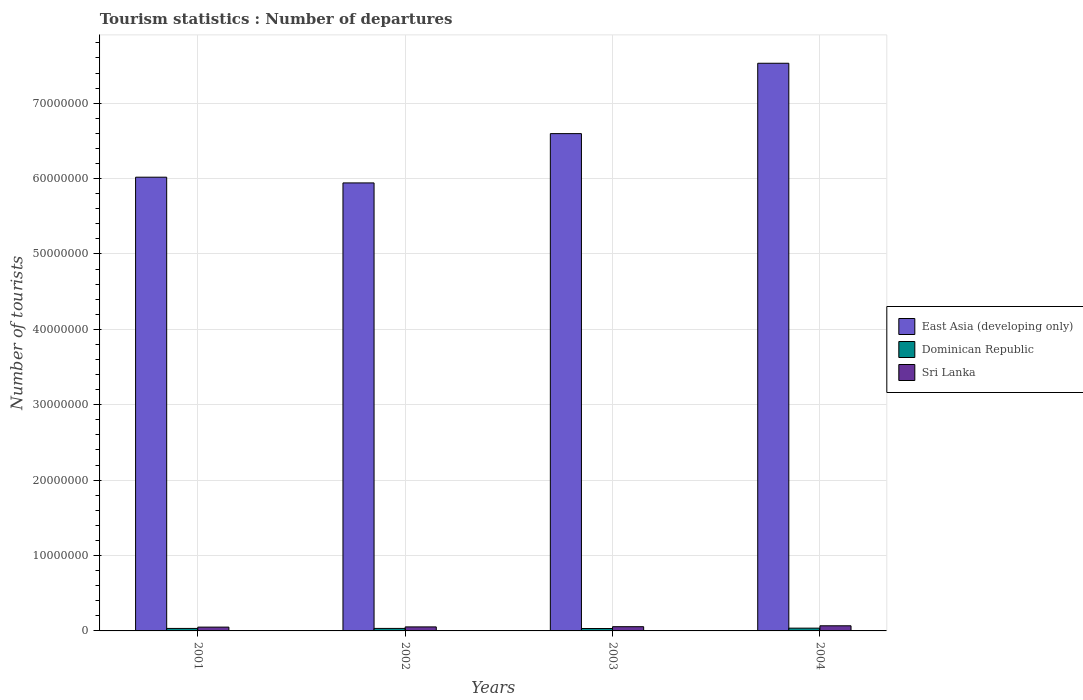How many groups of bars are there?
Your answer should be very brief. 4. Are the number of bars on each tick of the X-axis equal?
Keep it short and to the point. Yes. How many bars are there on the 2nd tick from the left?
Ensure brevity in your answer.  3. What is the number of tourist departures in East Asia (developing only) in 2004?
Provide a succinct answer. 7.53e+07. Across all years, what is the maximum number of tourist departures in East Asia (developing only)?
Make the answer very short. 7.53e+07. Across all years, what is the minimum number of tourist departures in Sri Lanka?
Make the answer very short. 5.05e+05. In which year was the number of tourist departures in Sri Lanka maximum?
Provide a succinct answer. 2004. In which year was the number of tourist departures in Dominican Republic minimum?
Make the answer very short. 2003. What is the total number of tourist departures in Sri Lanka in the graph?
Your response must be concise. 2.28e+06. What is the difference between the number of tourist departures in Dominican Republic in 2002 and that in 2003?
Your answer should be compact. 1.10e+04. What is the difference between the number of tourist departures in Sri Lanka in 2001 and the number of tourist departures in Dominican Republic in 2004?
Make the answer very short. 1.37e+05. What is the average number of tourist departures in East Asia (developing only) per year?
Ensure brevity in your answer.  6.52e+07. In the year 2001, what is the difference between the number of tourist departures in Sri Lanka and number of tourist departures in East Asia (developing only)?
Ensure brevity in your answer.  -5.97e+07. In how many years, is the number of tourist departures in Sri Lanka greater than 28000000?
Make the answer very short. 0. What is the ratio of the number of tourist departures in Dominican Republic in 2002 to that in 2004?
Provide a short and direct response. 0.9. Is the number of tourist departures in Dominican Republic in 2001 less than that in 2004?
Offer a very short reply. Yes. Is the difference between the number of tourist departures in Sri Lanka in 2002 and 2003 greater than the difference between the number of tourist departures in East Asia (developing only) in 2002 and 2003?
Keep it short and to the point. Yes. What is the difference between the highest and the second highest number of tourist departures in East Asia (developing only)?
Your answer should be very brief. 9.33e+06. What is the difference between the highest and the lowest number of tourist departures in Sri Lanka?
Give a very brief answer. 1.75e+05. In how many years, is the number of tourist departures in Dominican Republic greater than the average number of tourist departures in Dominican Republic taken over all years?
Provide a short and direct response. 1. Is the sum of the number of tourist departures in Sri Lanka in 2001 and 2004 greater than the maximum number of tourist departures in East Asia (developing only) across all years?
Provide a short and direct response. No. What does the 3rd bar from the left in 2003 represents?
Make the answer very short. Sri Lanka. What does the 2nd bar from the right in 2001 represents?
Ensure brevity in your answer.  Dominican Republic. How many years are there in the graph?
Offer a very short reply. 4. Are the values on the major ticks of Y-axis written in scientific E-notation?
Offer a very short reply. No. Does the graph contain any zero values?
Your answer should be compact. No. Where does the legend appear in the graph?
Make the answer very short. Center right. How many legend labels are there?
Your response must be concise. 3. What is the title of the graph?
Ensure brevity in your answer.  Tourism statistics : Number of departures. Does "Romania" appear as one of the legend labels in the graph?
Offer a very short reply. No. What is the label or title of the Y-axis?
Your response must be concise. Number of tourists. What is the Number of tourists in East Asia (developing only) in 2001?
Provide a short and direct response. 6.02e+07. What is the Number of tourists in Dominican Republic in 2001?
Give a very brief answer. 3.31e+05. What is the Number of tourists of Sri Lanka in 2001?
Make the answer very short. 5.05e+05. What is the Number of tourists in East Asia (developing only) in 2002?
Give a very brief answer. 5.94e+07. What is the Number of tourists in Dominican Republic in 2002?
Ensure brevity in your answer.  3.32e+05. What is the Number of tourists of Sri Lanka in 2002?
Provide a short and direct response. 5.33e+05. What is the Number of tourists in East Asia (developing only) in 2003?
Offer a terse response. 6.60e+07. What is the Number of tourists of Dominican Republic in 2003?
Your answer should be compact. 3.21e+05. What is the Number of tourists in Sri Lanka in 2003?
Provide a short and direct response. 5.61e+05. What is the Number of tourists of East Asia (developing only) in 2004?
Give a very brief answer. 7.53e+07. What is the Number of tourists in Dominican Republic in 2004?
Ensure brevity in your answer.  3.68e+05. What is the Number of tourists of Sri Lanka in 2004?
Keep it short and to the point. 6.80e+05. Across all years, what is the maximum Number of tourists of East Asia (developing only)?
Make the answer very short. 7.53e+07. Across all years, what is the maximum Number of tourists of Dominican Republic?
Give a very brief answer. 3.68e+05. Across all years, what is the maximum Number of tourists in Sri Lanka?
Make the answer very short. 6.80e+05. Across all years, what is the minimum Number of tourists in East Asia (developing only)?
Provide a succinct answer. 5.94e+07. Across all years, what is the minimum Number of tourists of Dominican Republic?
Your answer should be compact. 3.21e+05. Across all years, what is the minimum Number of tourists of Sri Lanka?
Your response must be concise. 5.05e+05. What is the total Number of tourists in East Asia (developing only) in the graph?
Make the answer very short. 2.61e+08. What is the total Number of tourists of Dominican Republic in the graph?
Your response must be concise. 1.35e+06. What is the total Number of tourists of Sri Lanka in the graph?
Ensure brevity in your answer.  2.28e+06. What is the difference between the Number of tourists of East Asia (developing only) in 2001 and that in 2002?
Provide a short and direct response. 7.60e+05. What is the difference between the Number of tourists of Dominican Republic in 2001 and that in 2002?
Your answer should be compact. -1000. What is the difference between the Number of tourists in Sri Lanka in 2001 and that in 2002?
Keep it short and to the point. -2.80e+04. What is the difference between the Number of tourists of East Asia (developing only) in 2001 and that in 2003?
Provide a succinct answer. -5.78e+06. What is the difference between the Number of tourists of Dominican Republic in 2001 and that in 2003?
Offer a very short reply. 10000. What is the difference between the Number of tourists of Sri Lanka in 2001 and that in 2003?
Provide a short and direct response. -5.60e+04. What is the difference between the Number of tourists in East Asia (developing only) in 2001 and that in 2004?
Ensure brevity in your answer.  -1.51e+07. What is the difference between the Number of tourists in Dominican Republic in 2001 and that in 2004?
Offer a terse response. -3.70e+04. What is the difference between the Number of tourists in Sri Lanka in 2001 and that in 2004?
Offer a terse response. -1.75e+05. What is the difference between the Number of tourists in East Asia (developing only) in 2002 and that in 2003?
Provide a succinct answer. -6.54e+06. What is the difference between the Number of tourists of Dominican Republic in 2002 and that in 2003?
Your answer should be compact. 1.10e+04. What is the difference between the Number of tourists in Sri Lanka in 2002 and that in 2003?
Your answer should be compact. -2.80e+04. What is the difference between the Number of tourists of East Asia (developing only) in 2002 and that in 2004?
Give a very brief answer. -1.59e+07. What is the difference between the Number of tourists in Dominican Republic in 2002 and that in 2004?
Your response must be concise. -3.60e+04. What is the difference between the Number of tourists of Sri Lanka in 2002 and that in 2004?
Your answer should be compact. -1.47e+05. What is the difference between the Number of tourists of East Asia (developing only) in 2003 and that in 2004?
Keep it short and to the point. -9.33e+06. What is the difference between the Number of tourists in Dominican Republic in 2003 and that in 2004?
Ensure brevity in your answer.  -4.70e+04. What is the difference between the Number of tourists of Sri Lanka in 2003 and that in 2004?
Ensure brevity in your answer.  -1.19e+05. What is the difference between the Number of tourists of East Asia (developing only) in 2001 and the Number of tourists of Dominican Republic in 2002?
Provide a succinct answer. 5.99e+07. What is the difference between the Number of tourists of East Asia (developing only) in 2001 and the Number of tourists of Sri Lanka in 2002?
Make the answer very short. 5.97e+07. What is the difference between the Number of tourists in Dominican Republic in 2001 and the Number of tourists in Sri Lanka in 2002?
Provide a succinct answer. -2.02e+05. What is the difference between the Number of tourists of East Asia (developing only) in 2001 and the Number of tourists of Dominican Republic in 2003?
Your response must be concise. 5.99e+07. What is the difference between the Number of tourists in East Asia (developing only) in 2001 and the Number of tourists in Sri Lanka in 2003?
Provide a succinct answer. 5.96e+07. What is the difference between the Number of tourists of East Asia (developing only) in 2001 and the Number of tourists of Dominican Republic in 2004?
Provide a short and direct response. 5.98e+07. What is the difference between the Number of tourists in East Asia (developing only) in 2001 and the Number of tourists in Sri Lanka in 2004?
Your answer should be compact. 5.95e+07. What is the difference between the Number of tourists in Dominican Republic in 2001 and the Number of tourists in Sri Lanka in 2004?
Give a very brief answer. -3.49e+05. What is the difference between the Number of tourists in East Asia (developing only) in 2002 and the Number of tourists in Dominican Republic in 2003?
Make the answer very short. 5.91e+07. What is the difference between the Number of tourists of East Asia (developing only) in 2002 and the Number of tourists of Sri Lanka in 2003?
Give a very brief answer. 5.89e+07. What is the difference between the Number of tourists in Dominican Republic in 2002 and the Number of tourists in Sri Lanka in 2003?
Your answer should be very brief. -2.29e+05. What is the difference between the Number of tourists in East Asia (developing only) in 2002 and the Number of tourists in Dominican Republic in 2004?
Make the answer very short. 5.91e+07. What is the difference between the Number of tourists of East Asia (developing only) in 2002 and the Number of tourists of Sri Lanka in 2004?
Offer a very short reply. 5.87e+07. What is the difference between the Number of tourists of Dominican Republic in 2002 and the Number of tourists of Sri Lanka in 2004?
Your response must be concise. -3.48e+05. What is the difference between the Number of tourists of East Asia (developing only) in 2003 and the Number of tourists of Dominican Republic in 2004?
Your answer should be compact. 6.56e+07. What is the difference between the Number of tourists of East Asia (developing only) in 2003 and the Number of tourists of Sri Lanka in 2004?
Provide a short and direct response. 6.53e+07. What is the difference between the Number of tourists of Dominican Republic in 2003 and the Number of tourists of Sri Lanka in 2004?
Give a very brief answer. -3.59e+05. What is the average Number of tourists in East Asia (developing only) per year?
Provide a short and direct response. 6.52e+07. What is the average Number of tourists of Dominican Republic per year?
Ensure brevity in your answer.  3.38e+05. What is the average Number of tourists in Sri Lanka per year?
Your response must be concise. 5.70e+05. In the year 2001, what is the difference between the Number of tourists of East Asia (developing only) and Number of tourists of Dominican Republic?
Ensure brevity in your answer.  5.99e+07. In the year 2001, what is the difference between the Number of tourists in East Asia (developing only) and Number of tourists in Sri Lanka?
Make the answer very short. 5.97e+07. In the year 2001, what is the difference between the Number of tourists in Dominican Republic and Number of tourists in Sri Lanka?
Make the answer very short. -1.74e+05. In the year 2002, what is the difference between the Number of tourists of East Asia (developing only) and Number of tourists of Dominican Republic?
Your response must be concise. 5.91e+07. In the year 2002, what is the difference between the Number of tourists of East Asia (developing only) and Number of tourists of Sri Lanka?
Your answer should be compact. 5.89e+07. In the year 2002, what is the difference between the Number of tourists of Dominican Republic and Number of tourists of Sri Lanka?
Make the answer very short. -2.01e+05. In the year 2003, what is the difference between the Number of tourists in East Asia (developing only) and Number of tourists in Dominican Republic?
Your answer should be compact. 6.56e+07. In the year 2003, what is the difference between the Number of tourists of East Asia (developing only) and Number of tourists of Sri Lanka?
Make the answer very short. 6.54e+07. In the year 2003, what is the difference between the Number of tourists in Dominican Republic and Number of tourists in Sri Lanka?
Your response must be concise. -2.40e+05. In the year 2004, what is the difference between the Number of tourists of East Asia (developing only) and Number of tourists of Dominican Republic?
Make the answer very short. 7.49e+07. In the year 2004, what is the difference between the Number of tourists of East Asia (developing only) and Number of tourists of Sri Lanka?
Keep it short and to the point. 7.46e+07. In the year 2004, what is the difference between the Number of tourists in Dominican Republic and Number of tourists in Sri Lanka?
Provide a short and direct response. -3.12e+05. What is the ratio of the Number of tourists in East Asia (developing only) in 2001 to that in 2002?
Offer a terse response. 1.01. What is the ratio of the Number of tourists in Dominican Republic in 2001 to that in 2002?
Offer a terse response. 1. What is the ratio of the Number of tourists in Sri Lanka in 2001 to that in 2002?
Your response must be concise. 0.95. What is the ratio of the Number of tourists of East Asia (developing only) in 2001 to that in 2003?
Ensure brevity in your answer.  0.91. What is the ratio of the Number of tourists of Dominican Republic in 2001 to that in 2003?
Your response must be concise. 1.03. What is the ratio of the Number of tourists in Sri Lanka in 2001 to that in 2003?
Ensure brevity in your answer.  0.9. What is the ratio of the Number of tourists of East Asia (developing only) in 2001 to that in 2004?
Provide a succinct answer. 0.8. What is the ratio of the Number of tourists in Dominican Republic in 2001 to that in 2004?
Your response must be concise. 0.9. What is the ratio of the Number of tourists in Sri Lanka in 2001 to that in 2004?
Offer a very short reply. 0.74. What is the ratio of the Number of tourists in East Asia (developing only) in 2002 to that in 2003?
Give a very brief answer. 0.9. What is the ratio of the Number of tourists of Dominican Republic in 2002 to that in 2003?
Offer a terse response. 1.03. What is the ratio of the Number of tourists in Sri Lanka in 2002 to that in 2003?
Provide a short and direct response. 0.95. What is the ratio of the Number of tourists in East Asia (developing only) in 2002 to that in 2004?
Ensure brevity in your answer.  0.79. What is the ratio of the Number of tourists of Dominican Republic in 2002 to that in 2004?
Offer a very short reply. 0.9. What is the ratio of the Number of tourists of Sri Lanka in 2002 to that in 2004?
Offer a terse response. 0.78. What is the ratio of the Number of tourists of East Asia (developing only) in 2003 to that in 2004?
Provide a short and direct response. 0.88. What is the ratio of the Number of tourists in Dominican Republic in 2003 to that in 2004?
Give a very brief answer. 0.87. What is the ratio of the Number of tourists in Sri Lanka in 2003 to that in 2004?
Provide a short and direct response. 0.82. What is the difference between the highest and the second highest Number of tourists of East Asia (developing only)?
Your answer should be very brief. 9.33e+06. What is the difference between the highest and the second highest Number of tourists of Dominican Republic?
Keep it short and to the point. 3.60e+04. What is the difference between the highest and the second highest Number of tourists in Sri Lanka?
Your response must be concise. 1.19e+05. What is the difference between the highest and the lowest Number of tourists of East Asia (developing only)?
Your answer should be very brief. 1.59e+07. What is the difference between the highest and the lowest Number of tourists in Dominican Republic?
Offer a very short reply. 4.70e+04. What is the difference between the highest and the lowest Number of tourists of Sri Lanka?
Make the answer very short. 1.75e+05. 